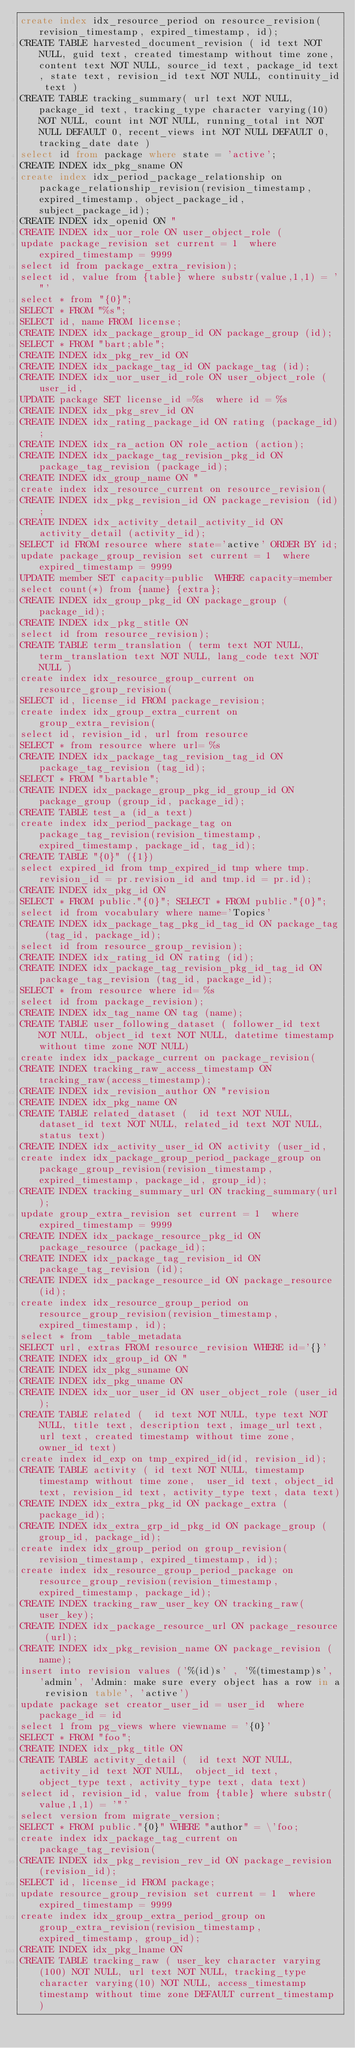Convert code to text. <code><loc_0><loc_0><loc_500><loc_500><_SQL_>create index idx_resource_period on resource_revision(revision_timestamp, expired_timestamp, id);
CREATE TABLE harvested_document_revision ( id text NOT NULL, guid text, created timestamp without time zone, content text NOT NULL, source_id text, package_id text, state text, revision_id text NOT NULL, continuity_id text )
CREATE TABLE tracking_summary( url text NOT NULL, package_id text, tracking_type character varying(10) NOT NULL, count int NOT NULL, running_total int NOT NULL DEFAULT 0, recent_views int NOT NULL DEFAULT 0, tracking_date date )
select id from package where state = 'active';
CREATE INDEX idx_pkg_sname ON 
create index idx_period_package_relationship on package_relationship_revision(revision_timestamp, expired_timestamp, object_package_id, subject_package_id);
CREATE INDEX idx_openid ON "
CREATE INDEX idx_uor_role ON user_object_role (
update package_revision set current = 1  where expired_timestamp = 9999
select id from package_extra_revision);
select id, value from {table} where substr(value,1,1) = '"' 
select * from "{0}";
SELECT * FROM "%s";
SELECT id, name FROM license;
CREATE INDEX idx_package_group_id ON package_group (id);
SELECT * FROM "bart;able";
CREATE INDEX idx_pkg_rev_id ON 
CREATE INDEX idx_package_tag_id ON package_tag (id);
CREATE INDEX idx_uor_user_id_role ON user_object_role (user_id,
UPDATE package SET license_id =%s  where id = %s
CREATE INDEX idx_pkg_srev_id ON 
CREATE INDEX idx_rating_package_id ON rating (package_id);
CREATE INDEX idx_ra_action ON role_action (action);
CREATE INDEX idx_package_tag_revision_pkg_id ON package_tag_revision (package_id);
CREATE INDEX idx_group_name ON "
create index idx_resource_current on resource_revision(
CREATE INDEX idx_pkg_revision_id ON package_revision (id);
CREATE INDEX idx_activity_detail_activity_id ON activity_detail (activity_id);
SELECT id FROM resource where state='active' ORDER BY id;
update package_group_revision set current = 1  where expired_timestamp = 9999
UPDATE member SET capacity=public  WHERE capacity=member
select count(*) from {name} {extra};
CREATE INDEX idx_group_pkg_id ON package_group (package_id);
CREATE INDEX idx_pkg_stitle ON 
select id from resource_revision);
CREATE TABLE term_translation ( term text NOT NULL, term_translation text NOT NULL, lang_code text NOT NULL )
create index idx_resource_group_current on resource_group_revision(
SELECT id, license_id FROM package_revision;
create index idx_group_extra_current on group_extra_revision(
select id, revision_id, url from resource 
SELECT * from resource where url= %s
CREATE INDEX idx_package_tag_revision_tag_id ON package_tag_revision (tag_id);
SELECT * FROM "bartable";
CREATE INDEX idx_package_group_pkg_id_group_id ON package_group (group_id, package_id);
CREATE TABLE test_a (id_a text)
create index idx_period_package_tag on package_tag_revision(revision_timestamp, expired_timestamp, package_id, tag_id);
CREATE TABLE "{0}" ({1})
select expired_id from tmp_expired_id tmp where tmp.revision_id = pr.revision_id and tmp.id = pr.id);
CREATE INDEX idx_pkg_id ON 
SELECT * FROM public."{0}"; SELECT * FROM public."{0}";
select id from vocabulary where name='Topics'
CREATE INDEX idx_package_tag_pkg_id_tag_id ON package_tag (tag_id, package_id);
select id from resource_group_revision);
CREATE INDEX idx_rating_id ON rating (id);
CREATE INDEX idx_package_tag_revision_pkg_id_tag_id ON package_tag_revision (tag_id, package_id);
SELECT * from resource where id= %s
select id from package_revision);
CREATE INDEX idx_tag_name ON tag (name);
CREATE TABLE user_following_dataset ( follower_id text NOT NULL, object_id text NOT NULL, datetime timestamp without time zone NOT NULL)
create index idx_package_current on package_revision(
CREATE INDEX tracking_raw_access_timestamp ON tracking_raw(access_timestamp);
CREATE INDEX idx_revision_author ON "revision
CREATE INDEX idx_pkg_name ON 
CREATE TABLE related_dataset (	id text NOT NULL,	dataset_id text NOT NULL,	related_id text NOT NULL,	status text)
CREATE INDEX idx_activity_user_id ON activity (user_id, 
create index idx_package_group_period_package_group on package_group_revision(revision_timestamp, expired_timestamp, package_id, group_id);
CREATE INDEX tracking_summary_url ON tracking_summary(url);
update group_extra_revision set current = 1  where expired_timestamp = 9999
CREATE INDEX idx_package_resource_pkg_id ON package_resource (package_id);
CREATE INDEX idx_package_tag_revision_id ON package_tag_revision (id);
CREATE INDEX idx_package_resource_id ON package_resource (id);
create index idx_resource_group_period on resource_group_revision(revision_timestamp, expired_timestamp, id);
select * from _table_metadata 
SELECT url, extras FROM resource_revision WHERE id='{}'
CREATE INDEX idx_group_id ON "
CREATE INDEX idx_pkg_suname ON 
CREATE INDEX idx_pkg_uname ON 
CREATE INDEX idx_uor_user_id ON user_object_role (user_id);
CREATE TABLE related (	id text NOT NULL,	type text NOT NULL,	title text,	description text,	image_url text,	url text,	created timestamp without time zone,	owner_id text)
create index id_exp on tmp_expired_id(id, revision_id);
CREATE TABLE activity (	id text NOT NULL,	timestamp timestamp without time zone,	user_id text,	object_id text,	revision_id text,	activity_type text,	data text)
CREATE INDEX idx_extra_pkg_id ON package_extra (package_id);
CREATE INDEX idx_extra_grp_id_pkg_id ON package_group (group_id, package_id);
create index idx_group_period on group_revision(revision_timestamp, expired_timestamp, id);
create index idx_resource_group_period_package on resource_group_revision(revision_timestamp, expired_timestamp, package_id);
CREATE INDEX tracking_raw_user_key ON tracking_raw(user_key);
CREATE INDEX idx_package_resource_url ON package_resource (url);
CREATE INDEX idx_pkg_revision_name ON package_revision (name);
insert into revision values ('%(id)s' , '%(timestamp)s', 'admin', 'Admin: make sure every object has a row in a revision table', 'active')
update package set creator_user_id = user_id  where package_id = id
select 1 from pg_views where viewname = '{0}'
SELECT * FROM "foo";
CREATE INDEX idx_pkg_title ON 
CREATE TABLE activity_detail (	id text NOT NULL,	activity_id text NOT NULL,	object_id text,	object_type text,	activity_type text,	data text)
select id, revision_id, value from {table} where substr(value,1,1) = '"' 
select version from migrate_version;
SELECT * FROM public."{0}" WHERE "author" = \'foo;
create index idx_package_tag_current on package_tag_revision(
CREATE INDEX idx_pkg_revision_rev_id ON package_revision (revision_id);
SELECT id, license_id FROM package;
update resource_group_revision set current = 1  where expired_timestamp = 9999
create index idx_group_extra_period_group on group_extra_revision(revision_timestamp, expired_timestamp, group_id);
CREATE INDEX idx_pkg_lname ON 
CREATE TABLE tracking_raw ( user_key character varying(100) NOT NULL, url text NOT NULL, tracking_type character varying(10) NOT NULL, access_timestamp timestamp without time zone DEFAULT current_timestamp )</code> 